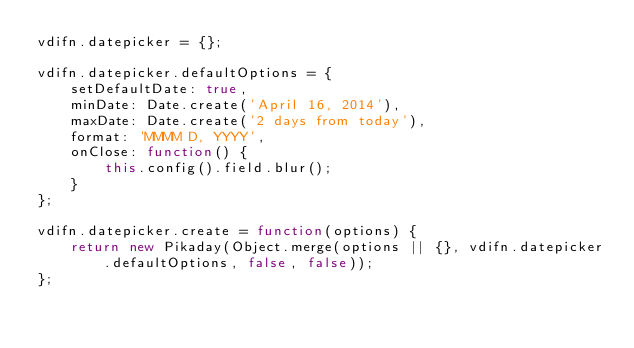Convert code to text. <code><loc_0><loc_0><loc_500><loc_500><_JavaScript_>vdifn.datepicker = {};

vdifn.datepicker.defaultOptions = {
    setDefaultDate: true,
    minDate: Date.create('April 16, 2014'),
    maxDate: Date.create('2 days from today'),
    format: 'MMMM D, YYYY',
    onClose: function() {
        this.config().field.blur();
    }
};

vdifn.datepicker.create = function(options) {
    return new Pikaday(Object.merge(options || {}, vdifn.datepicker.defaultOptions, false, false));
};
</code> 